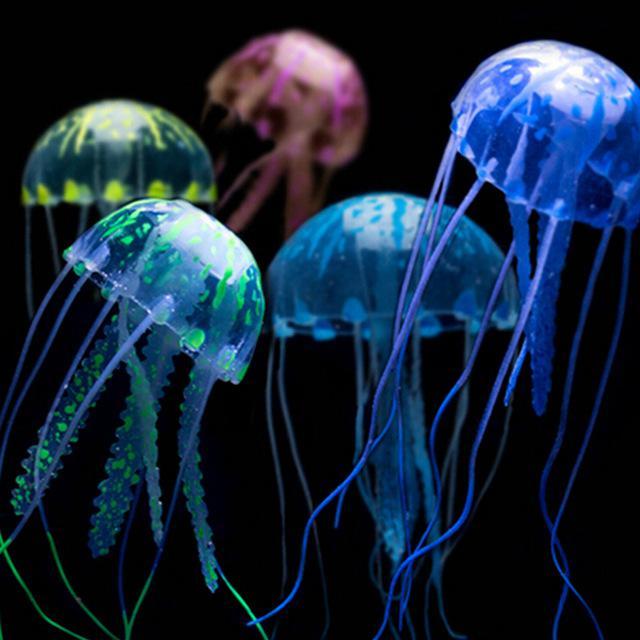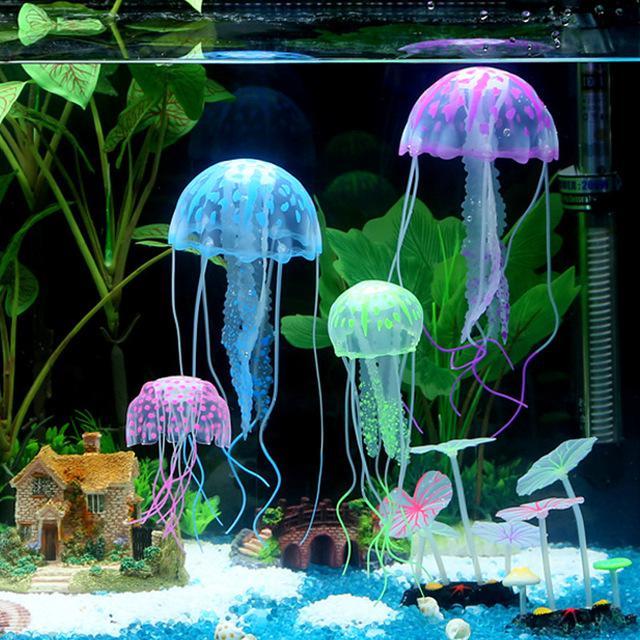The first image is the image on the left, the second image is the image on the right. Analyze the images presented: Is the assertion "One image in the pair shows jellyfish of all one color while the other shows jellyfish in a variety of colors." valid? Answer yes or no. No. The first image is the image on the left, the second image is the image on the right. Considering the images on both sides, is "Each image features different colors of jellyfish with long tentacles dangling downward, and the right image features jellyfish in an aquarium tank with green plants." valid? Answer yes or no. Yes. 